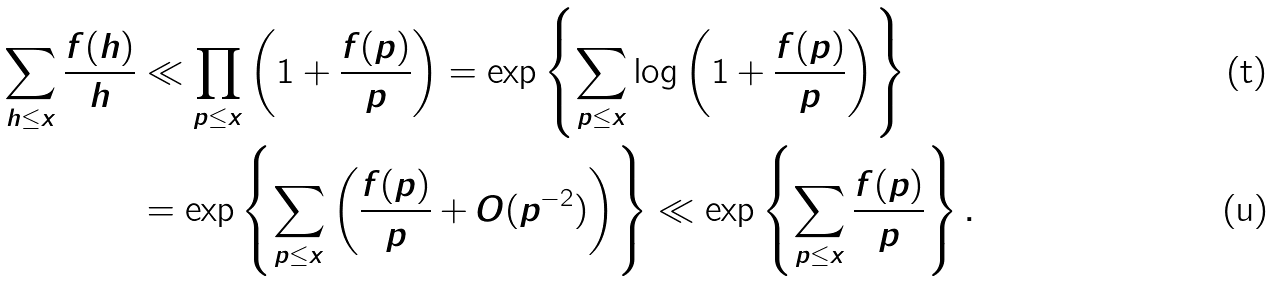Convert formula to latex. <formula><loc_0><loc_0><loc_500><loc_500>\sum _ { h \leq x } \frac { f ( h ) } { h } & \ll \prod _ { p \leq x } \left ( 1 + \frac { f ( p ) } { p } \right ) = \exp \left \{ \sum _ { p \leq x } \log \left ( 1 + \frac { f ( p ) } { p } \right ) \right \} \\ & = \exp \left \{ \sum _ { p \leq x } \left ( \frac { f ( p ) } { p } + O ( p ^ { - 2 } ) \right ) \right \} \ll \exp \left \{ \sum _ { p \leq x } \frac { f ( p ) } { p } \right \} .</formula> 